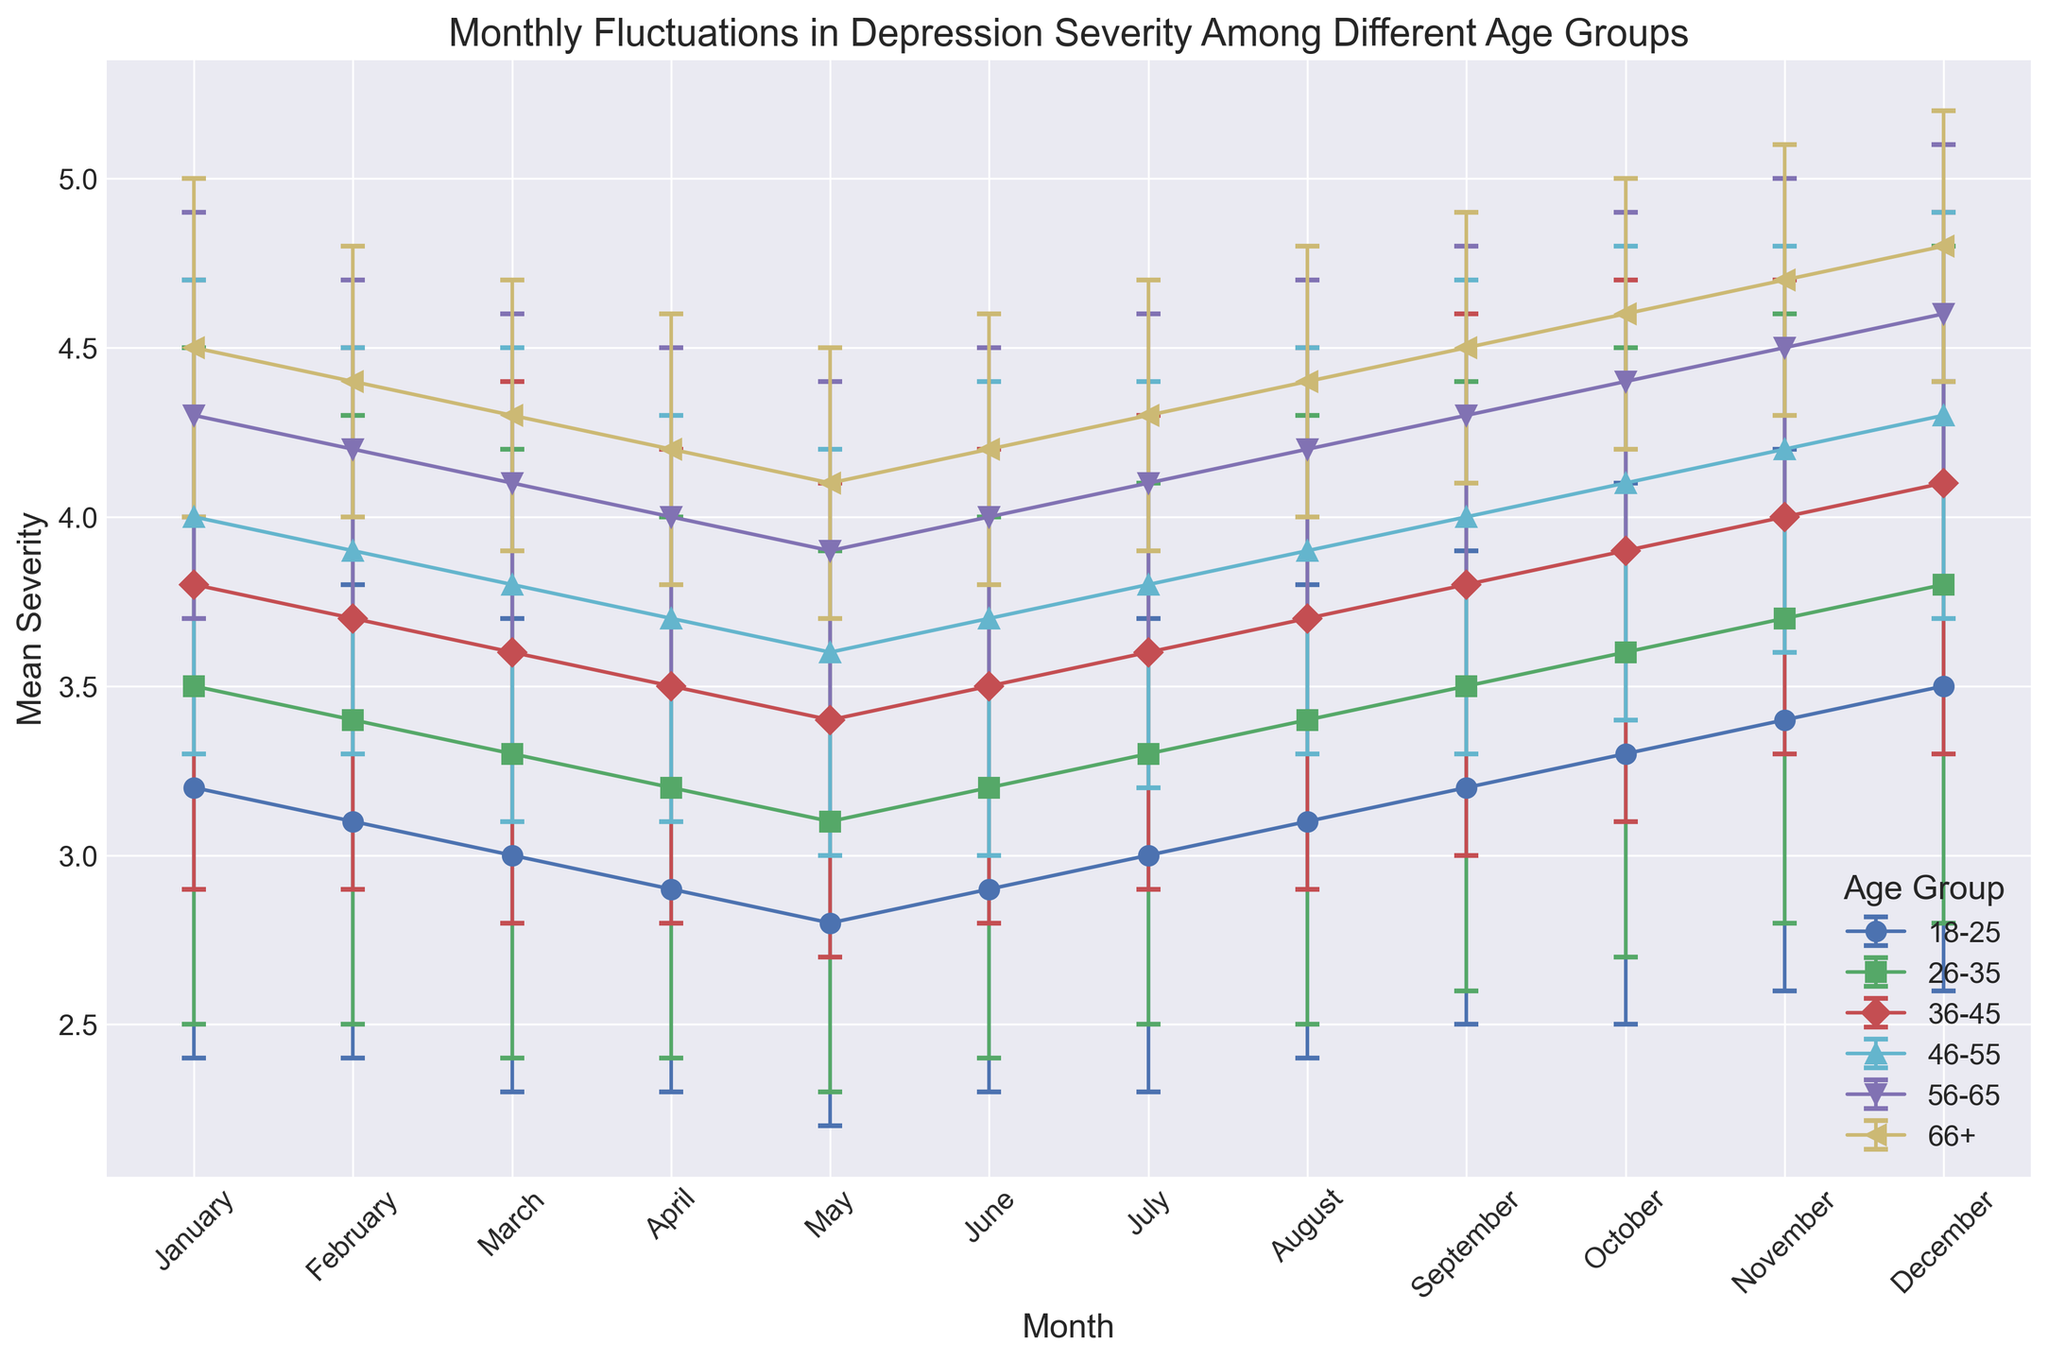Which age group has the highest mean depression severity in December? To find the highest mean depression severity in December, look at the December mean severity values for each age group. Determine the largest value.
Answer: 66+ How does the mean depression severity of the 18-25 age group in January compare to April? Compare the mean severity of the 18-25 age group in January and April. The value in January is 3.2 and in April is 2.9.
Answer: Higher in January Which month has the highest mean severity for the 26-35 age group? Look along the data trend for the 26-35 age group for each month and identify the month where the mean severity is highest.
Answer: December Is the mean severity for the 56-65 age group generally increasing, decreasing, or remaining stable throughout the year? Observe the mean severity values for the 56-65 age group across the months and see if the values show a trend of increasing, decreasing, or stability.
Answer: Increasing What is the difference in mean severity between the 36-45 and 18-25 age groups in March? Subtract the mean severity of the 18-25 age group from the 36-45 age group for March. Mean for 36-45 is 3.6, and for 18-25 is 3.0. 3.6 - 3.0 equals 0.6.
Answer: 0.6 Among all age groups, which has the least fluctuation in depression severity as indicated by the smallest standard deviation in April? Locate the age group with the lowest standard deviation value in April, which represents the least fluctuation.
Answer: 66+ Between September and October, which month shows a larger increase in mean severity for the 46-55 age group? Calculate the difference in mean severity for the 46-55 age group between August and September, and September and October. Compare these differences.
Answer: October For the 66+ age group, which two consecutive months have the smallest change in mean severity? Look at the differences in mean severity for the 66+ age group across all consecutive months and find the smallest change.
Answer: July and August What is the total mean severity for the 18-25 age group over the span of March, April, and May? Add the mean severity values for the 18-25 age group for March, April, and May. 3.0 (March) + 2.9 (April) + 2.8 (May) equals 8.7.
Answer: 8.7 